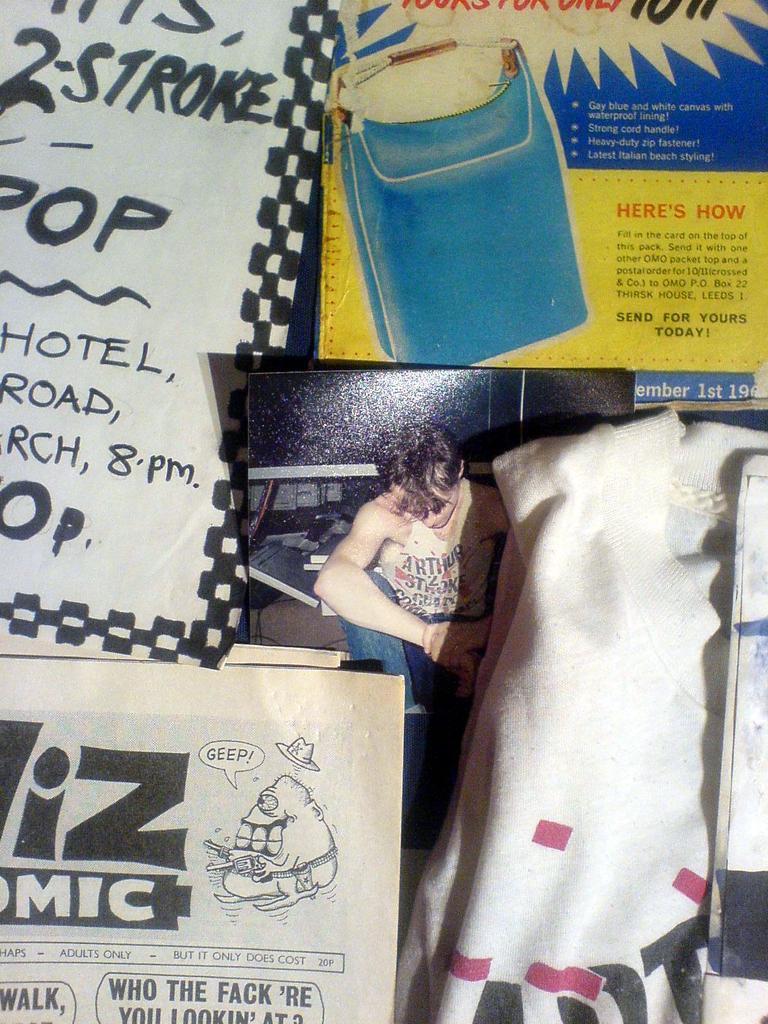Please provide a concise description of this image. In this image, we can see boards, papers and there is a cloth. 